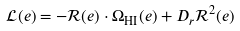<formula> <loc_0><loc_0><loc_500><loc_500>\mathcal { L } ( e ) = - \mathcal { R } ( e ) \cdot \Omega _ { \text {HI} } ( e ) + D _ { r } \mathcal { R } ^ { 2 } ( e )</formula> 